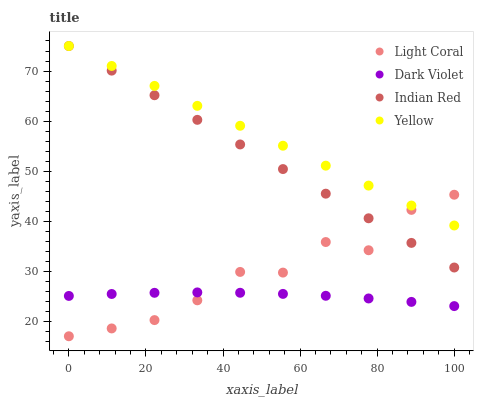Does Dark Violet have the minimum area under the curve?
Answer yes or no. Yes. Does Yellow have the maximum area under the curve?
Answer yes or no. Yes. Does Indian Red have the minimum area under the curve?
Answer yes or no. No. Does Indian Red have the maximum area under the curve?
Answer yes or no. No. Is Yellow the smoothest?
Answer yes or no. Yes. Is Light Coral the roughest?
Answer yes or no. Yes. Is Indian Red the smoothest?
Answer yes or no. No. Is Indian Red the roughest?
Answer yes or no. No. Does Light Coral have the lowest value?
Answer yes or no. Yes. Does Indian Red have the lowest value?
Answer yes or no. No. Does Indian Red have the highest value?
Answer yes or no. Yes. Does Dark Violet have the highest value?
Answer yes or no. No. Is Dark Violet less than Yellow?
Answer yes or no. Yes. Is Yellow greater than Dark Violet?
Answer yes or no. Yes. Does Indian Red intersect Light Coral?
Answer yes or no. Yes. Is Indian Red less than Light Coral?
Answer yes or no. No. Is Indian Red greater than Light Coral?
Answer yes or no. No. Does Dark Violet intersect Yellow?
Answer yes or no. No. 